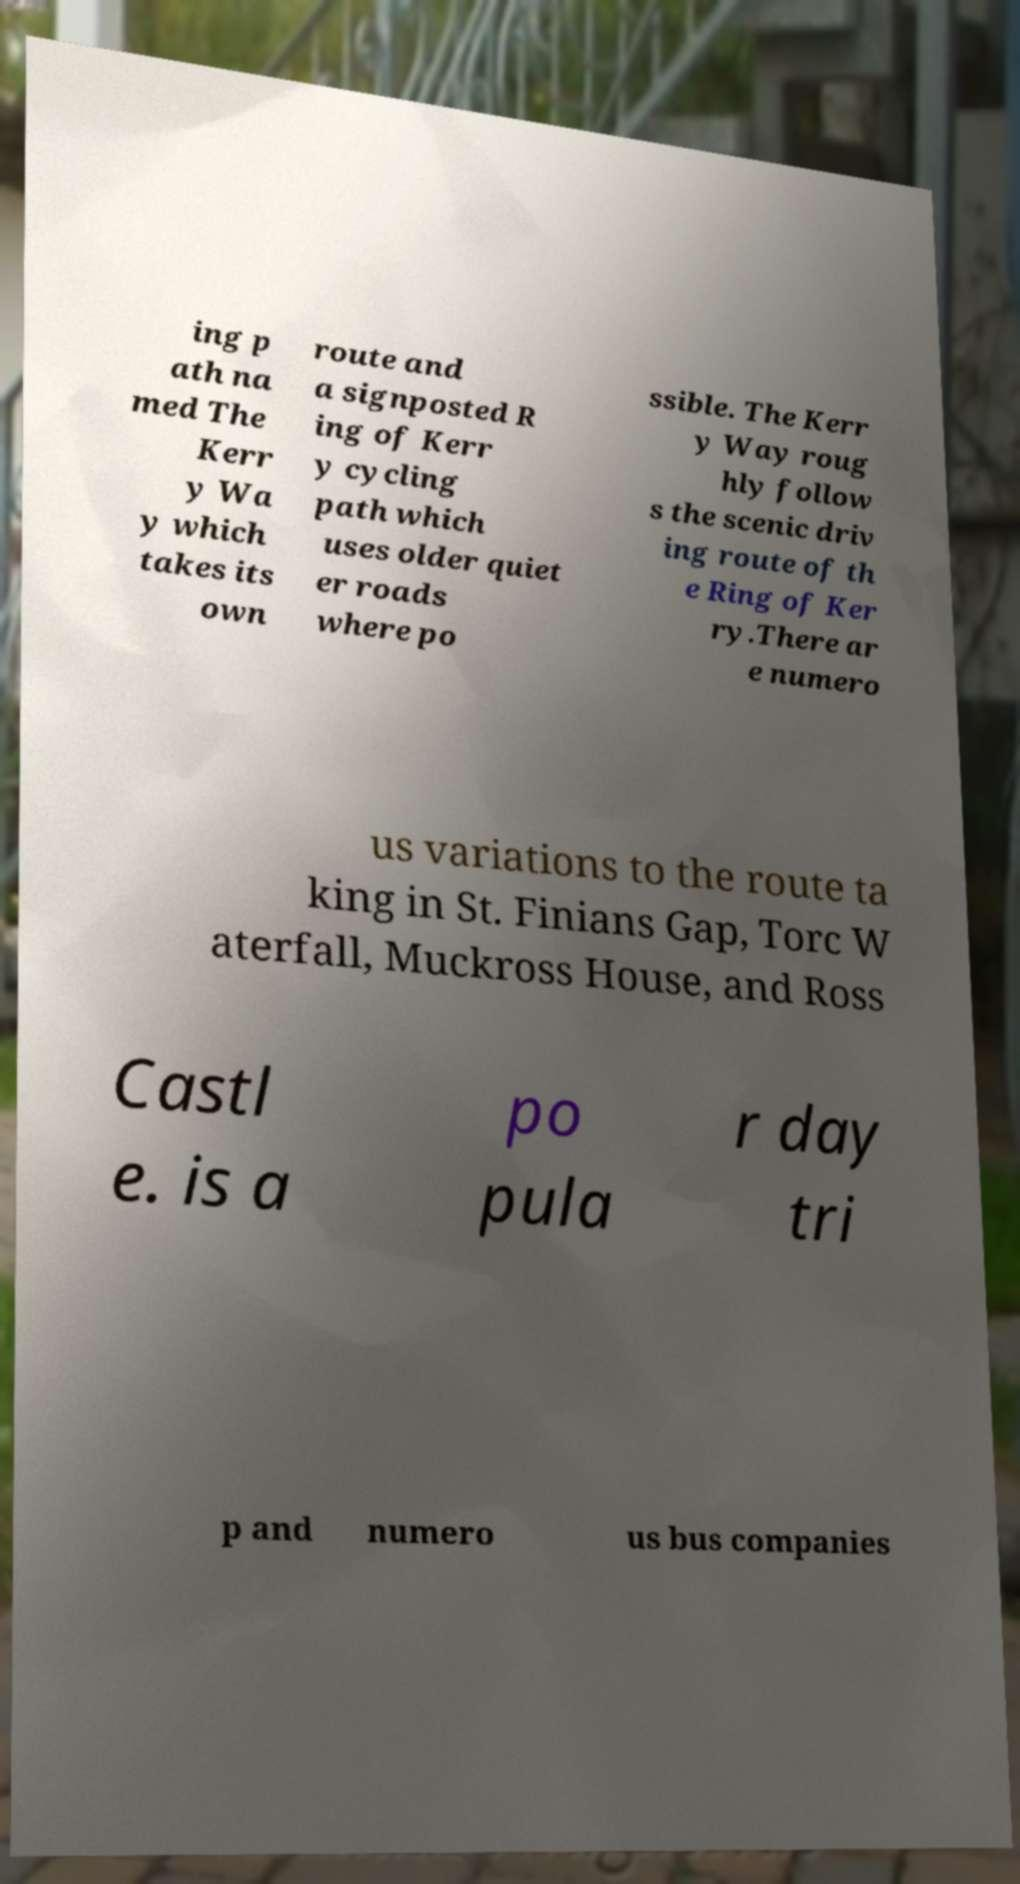Can you read and provide the text displayed in the image?This photo seems to have some interesting text. Can you extract and type it out for me? ing p ath na med The Kerr y Wa y which takes its own route and a signposted R ing of Kerr y cycling path which uses older quiet er roads where po ssible. The Kerr y Way roug hly follow s the scenic driv ing route of th e Ring of Ker ry.There ar e numero us variations to the route ta king in St. Finians Gap, Torc W aterfall, Muckross House, and Ross Castl e. is a po pula r day tri p and numero us bus companies 